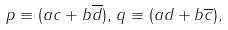<formula> <loc_0><loc_0><loc_500><loc_500>p \equiv ( a c + b \overline { d } ) , \, q \equiv ( a d + b \overline { c } ) ,</formula> 